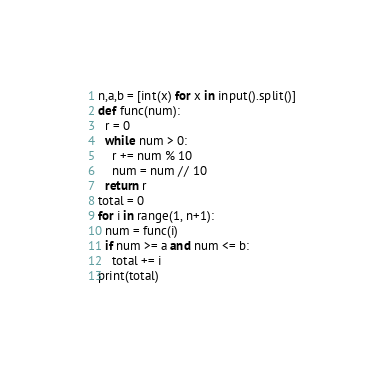Convert code to text. <code><loc_0><loc_0><loc_500><loc_500><_Python_>n,a,b = [int(x) for x in input().split()]
def func(num):
  r = 0
  while num > 0:
    r += num % 10
    num = num // 10
  return r
total = 0
for i in range(1, n+1):
  num = func(i)
  if num >= a and num <= b:
    total += i
print(total)
</code> 